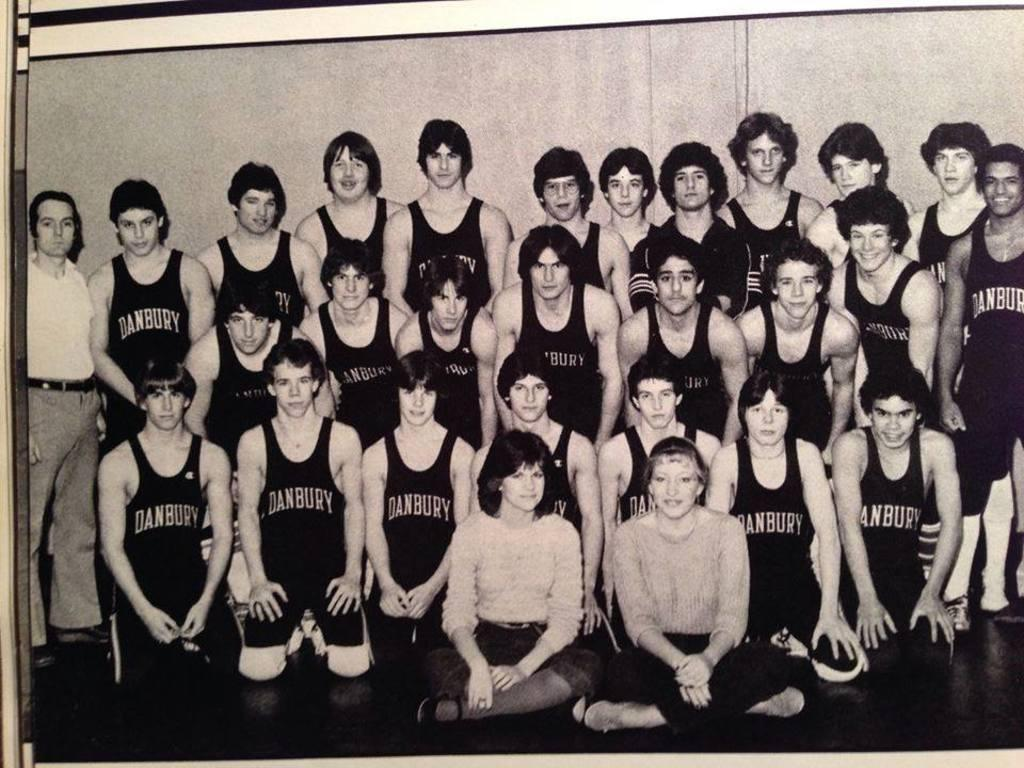<image>
Summarize the visual content of the image. An old photograph of a Danbury athletic team. 